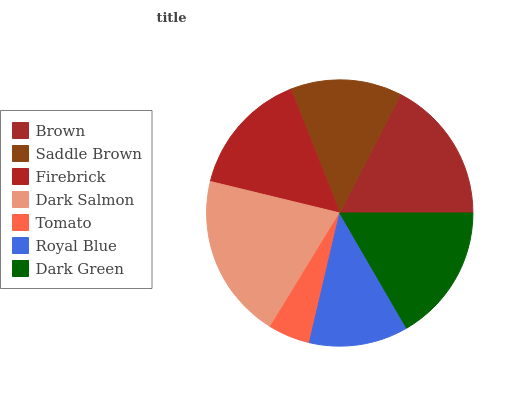Is Tomato the minimum?
Answer yes or no. Yes. Is Dark Salmon the maximum?
Answer yes or no. Yes. Is Saddle Brown the minimum?
Answer yes or no. No. Is Saddle Brown the maximum?
Answer yes or no. No. Is Brown greater than Saddle Brown?
Answer yes or no. Yes. Is Saddle Brown less than Brown?
Answer yes or no. Yes. Is Saddle Brown greater than Brown?
Answer yes or no. No. Is Brown less than Saddle Brown?
Answer yes or no. No. Is Firebrick the high median?
Answer yes or no. Yes. Is Firebrick the low median?
Answer yes or no. Yes. Is Saddle Brown the high median?
Answer yes or no. No. Is Dark Green the low median?
Answer yes or no. No. 